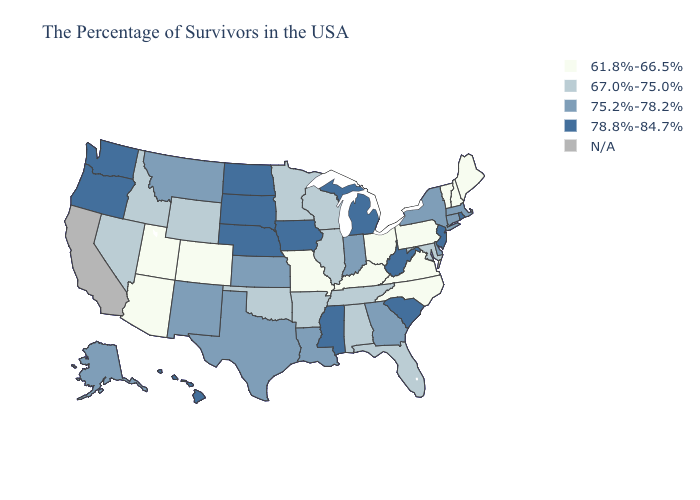Among the states that border Oregon , does Washington have the lowest value?
Concise answer only. No. Which states hav the highest value in the Northeast?
Quick response, please. Rhode Island, New Jersey. Does the map have missing data?
Short answer required. Yes. What is the lowest value in the USA?
Be succinct. 61.8%-66.5%. What is the value of Wisconsin?
Keep it brief. 67.0%-75.0%. Name the states that have a value in the range N/A?
Concise answer only. California. Name the states that have a value in the range N/A?
Short answer required. California. What is the lowest value in states that border New York?
Short answer required. 61.8%-66.5%. What is the lowest value in the USA?
Short answer required. 61.8%-66.5%. Name the states that have a value in the range 78.8%-84.7%?
Keep it brief. Rhode Island, New Jersey, South Carolina, West Virginia, Michigan, Mississippi, Iowa, Nebraska, South Dakota, North Dakota, Washington, Oregon, Hawaii. What is the value of California?
Write a very short answer. N/A. Does the first symbol in the legend represent the smallest category?
Concise answer only. Yes. What is the highest value in the USA?
Write a very short answer. 78.8%-84.7%. 